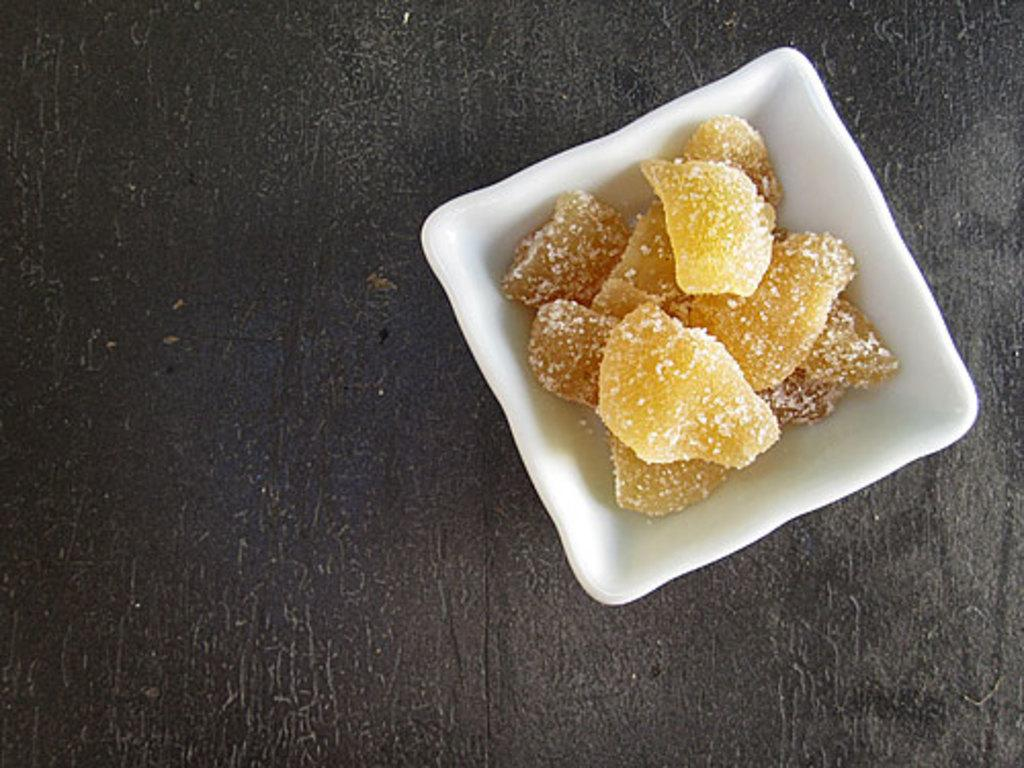What color is the bowl in the image? The bowl in the image is white. What is inside the bowl? The bowl contains sweets. Where is the bowl located? The bowl is placed on a table. What type of brass instrument can be seen in the image? There is no brass instrument present in the image; it features a white bowl containing sweets on a table. 